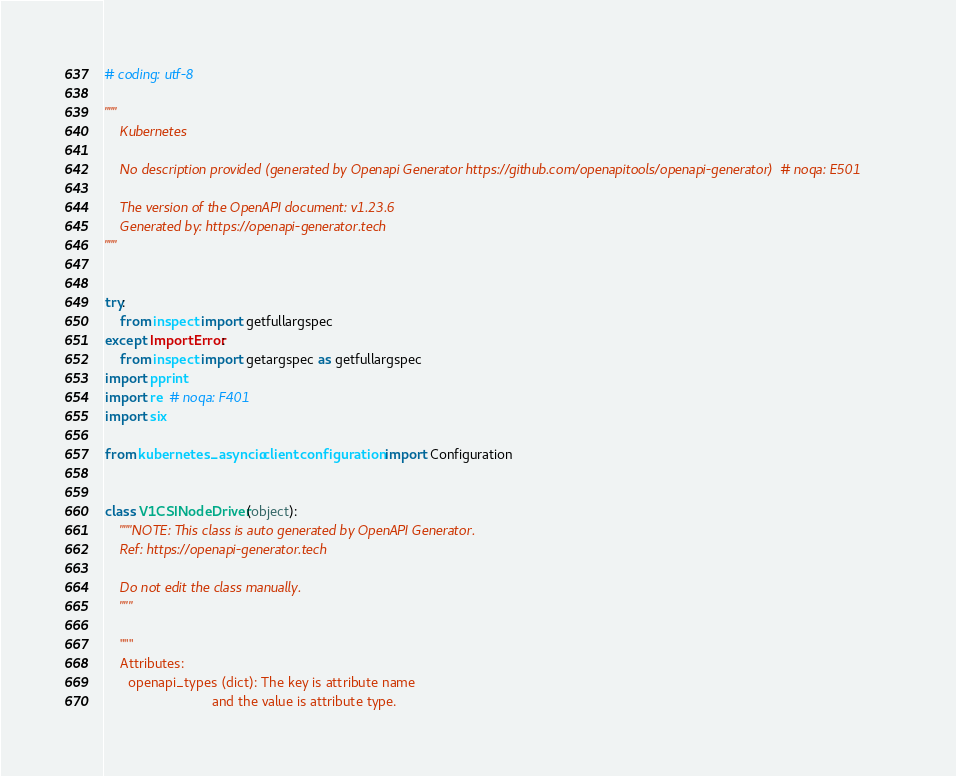Convert code to text. <code><loc_0><loc_0><loc_500><loc_500><_Python_># coding: utf-8

"""
    Kubernetes

    No description provided (generated by Openapi Generator https://github.com/openapitools/openapi-generator)  # noqa: E501

    The version of the OpenAPI document: v1.23.6
    Generated by: https://openapi-generator.tech
"""


try:
    from inspect import getfullargspec
except ImportError:
    from inspect import getargspec as getfullargspec
import pprint
import re  # noqa: F401
import six

from kubernetes_asyncio.client.configuration import Configuration


class V1CSINodeDriver(object):
    """NOTE: This class is auto generated by OpenAPI Generator.
    Ref: https://openapi-generator.tech

    Do not edit the class manually.
    """

    """
    Attributes:
      openapi_types (dict): The key is attribute name
                            and the value is attribute type.</code> 